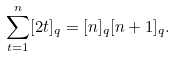<formula> <loc_0><loc_0><loc_500><loc_500>\sum _ { t = 1 } ^ { n } [ 2 t ] _ { q } = [ n ] _ { q } [ n + 1 ] _ { q } .</formula> 